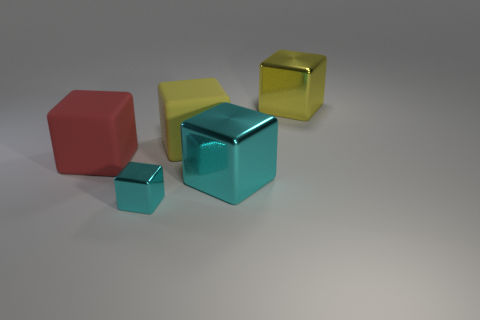There is a yellow matte object; does it have the same size as the metallic thing that is behind the red object?
Offer a terse response. Yes. Are there any big matte objects that have the same color as the tiny shiny object?
Offer a very short reply. No. What number of tiny objects are shiny balls or yellow things?
Offer a very short reply. 0. What number of tiny blue rubber things are there?
Provide a succinct answer. 0. What is the material of the big yellow cube that is in front of the big yellow metal thing?
Ensure brevity in your answer.  Rubber. There is a small cyan metallic block; are there any yellow matte things left of it?
Offer a terse response. No. Do the yellow shiny block and the yellow matte thing have the same size?
Make the answer very short. Yes. How many large yellow objects have the same material as the large red thing?
Offer a terse response. 1. What size is the matte cube that is to the left of the small cyan metallic thing to the right of the large red cube?
Ensure brevity in your answer.  Large. There is a thing that is to the left of the yellow rubber block and behind the large cyan metallic object; what is its color?
Offer a terse response. Red. 